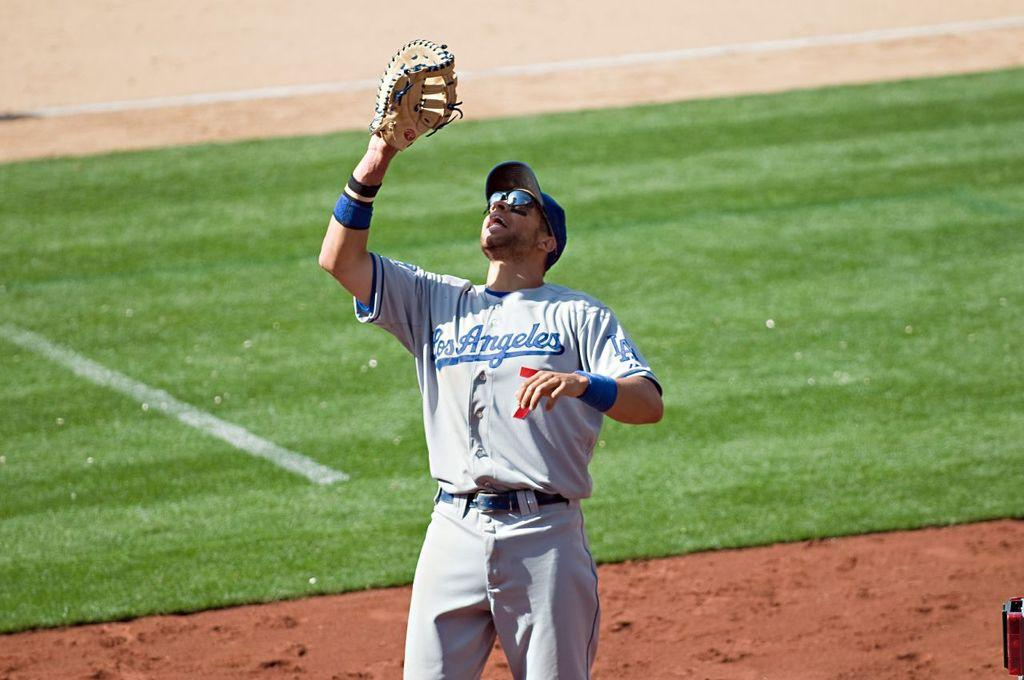<image>
Present a compact description of the photo's key features. A baseball player wears a Los Angeles uniform. 